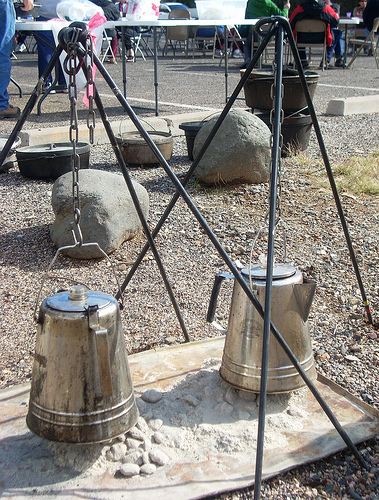<image>
Can you confirm if the coffee pot is to the left of the rocks? No. The coffee pot is not to the left of the rocks. From this viewpoint, they have a different horizontal relationship. 